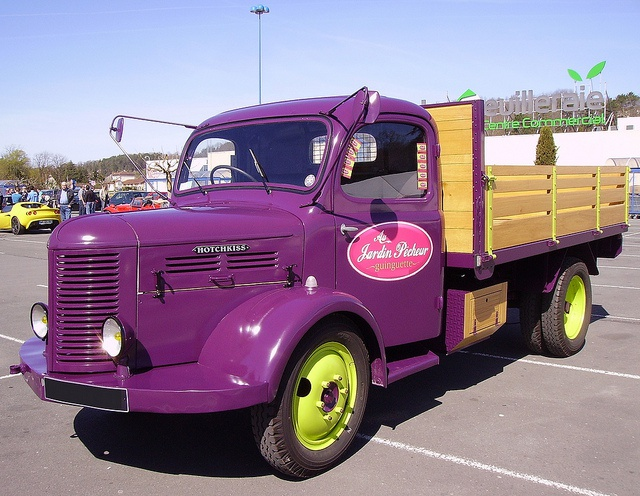Describe the objects in this image and their specific colors. I can see truck in lightblue, purple, and black tones, car in lightblue, khaki, black, and gray tones, car in lightblue, salmon, red, lightpink, and darkgray tones, people in lightblue, gray, lavender, and black tones, and car in lightblue, purple, gray, navy, and darkblue tones in this image. 